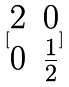Convert formula to latex. <formula><loc_0><loc_0><loc_500><loc_500>[ \begin{matrix} 2 & 0 \\ 0 & \frac { 1 } { 2 } \end{matrix} ]</formula> 